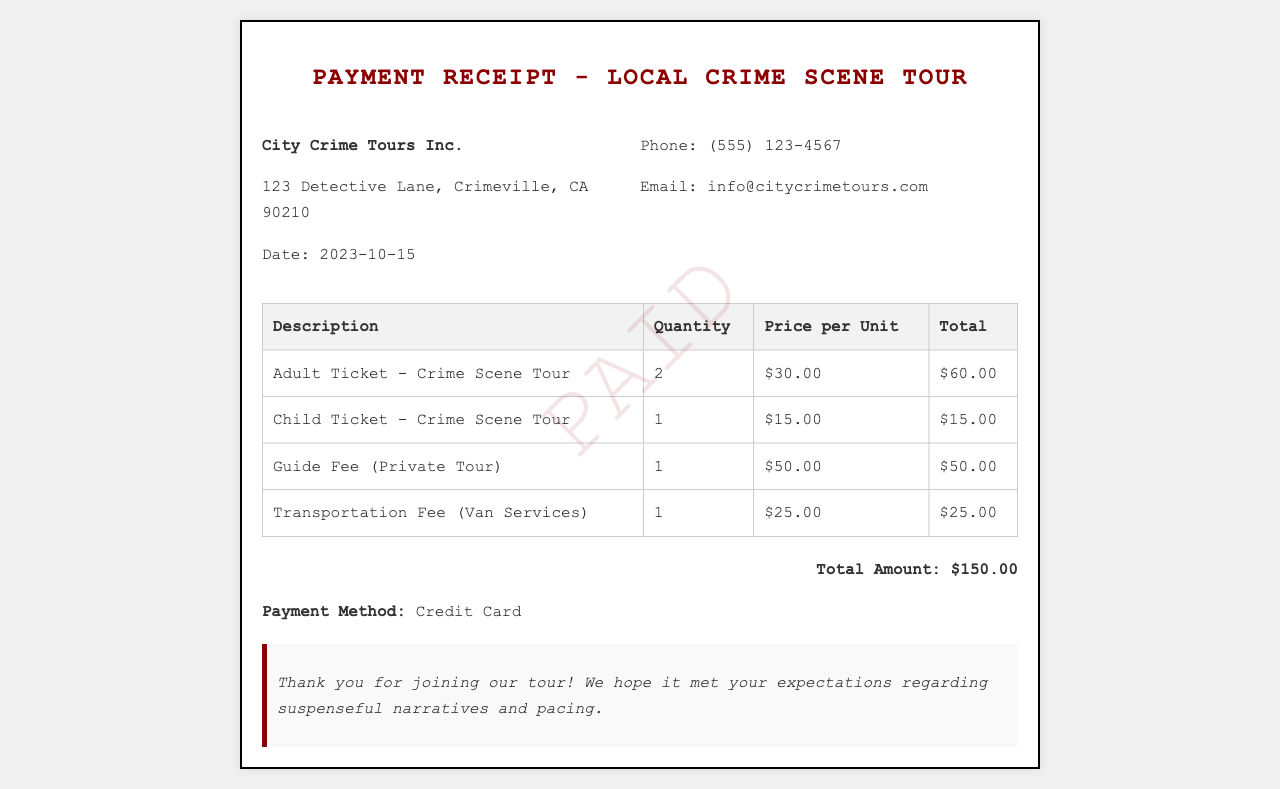What is the name of the organization? The organization name is mentioned at the top of the receipt.
Answer: City Crime Tours Inc What is the date of the tour? The date is listed in the document as part of the organization details.
Answer: 2023-10-15 How many adult tickets were purchased? The quantity of adult tickets is specified in the ticket description section.
Answer: 2 What is the price of a child ticket? The price per unit for a child ticket is stated in the respective row of the table.
Answer: $15.00 What is the total amount for the tour? The total amount is summarized at the bottom of the document as the final charge.
Answer: $150.00 How much is the guide fee? The guide fee is explicitly detailed in its corresponding row in the table.
Answer: $50.00 What payment method was used? The payment method is mentioned towards the end of the receipt.
Answer: Credit Card What service does the transportation fee cover? The specific service for which the transportation fee is charged is indicated in the table.
Answer: Van Services What is the target audience for this tour based on ticket types? The ticket types listed suggest which demographic is targeted for the tour.
Answer: Adults and Children 